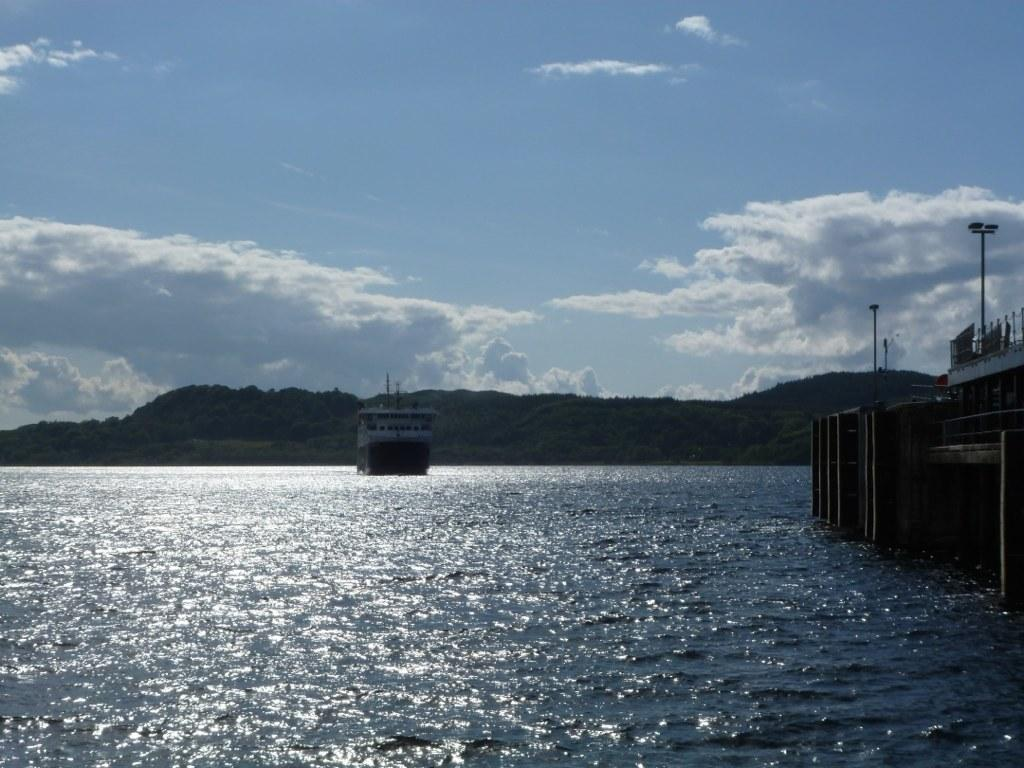What is the main subject of the image? There is a boat on the water in the image. What can be seen in the background of the image? Hills are visible in the background of the image. What is visible above the boat and hills? The sky is visible in the image, and clouds are present in the sky. What else can be seen on the water in the image? There is an unspecified object on the water on the right side. What structures are present in the image? There are poles in the image. Can you hear the sound of someone coughing in the image? There is no auditory information provided in the image, so it is impossible to determine if someone is coughing or not. What type of clover is growing on the hills in the background? There is no mention of clover in the image, and the hills are in the background, so it is impossible to determine if clover is present or not. 